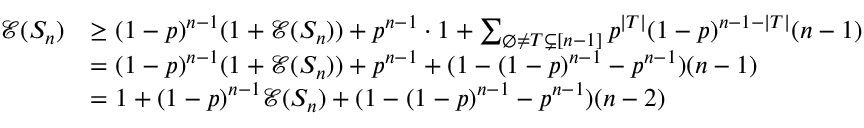<formula> <loc_0><loc_0><loc_500><loc_500>\begin{array} { r l } { \mathcal { E } ( S _ { n } ) } & { \geq ( 1 - p ) ^ { n - 1 } ( 1 + \mathcal { E } ( S _ { n } ) ) + p ^ { n - 1 } \cdot 1 + \sum _ { \emptyset \neq T \subsetneq [ n - 1 ] } p ^ { | T | } ( 1 - p ) ^ { n - 1 - | T | } ( n - 1 ) } \\ & { = ( 1 - p ) ^ { n - 1 } ( 1 + \mathcal { E } ( S _ { n } ) ) + p ^ { n - 1 } + ( 1 - ( 1 - p ) ^ { n - 1 } - p ^ { n - 1 } ) ( n - 1 ) } \\ & { = 1 + ( 1 - p ) ^ { n - 1 } \mathcal { E } ( S _ { n } ) + ( 1 - ( 1 - p ) ^ { n - 1 } - p ^ { n - 1 } ) ( n - 2 ) } \end{array}</formula> 